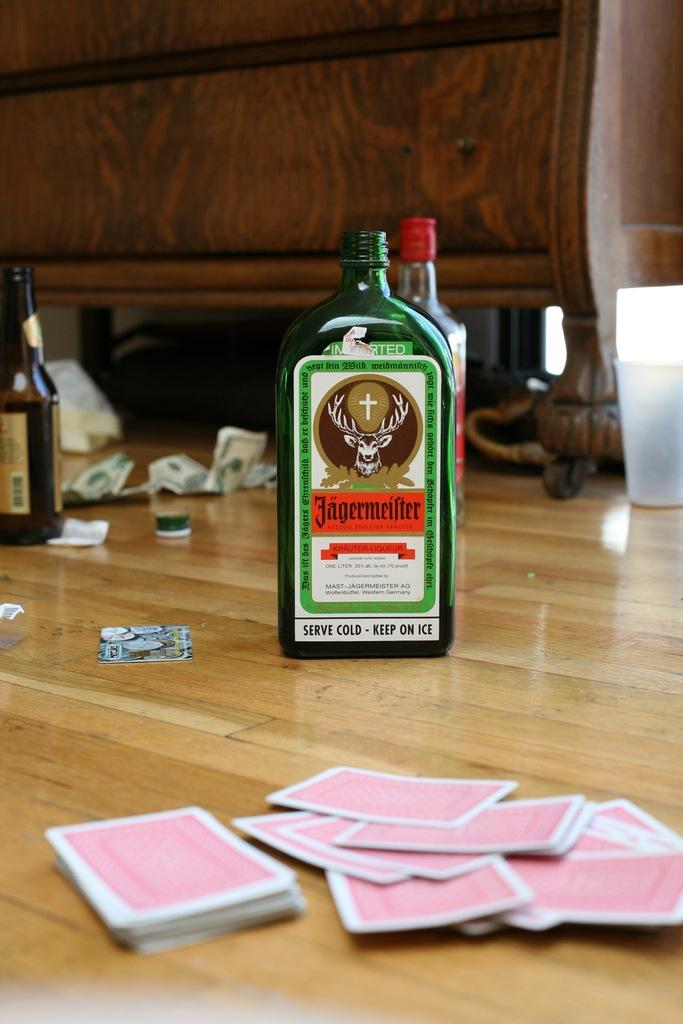<image>
Describe the image concisely. Several bottles including a green bottle of Jaegermeister on a wooden floor  next to some red playing cards. 